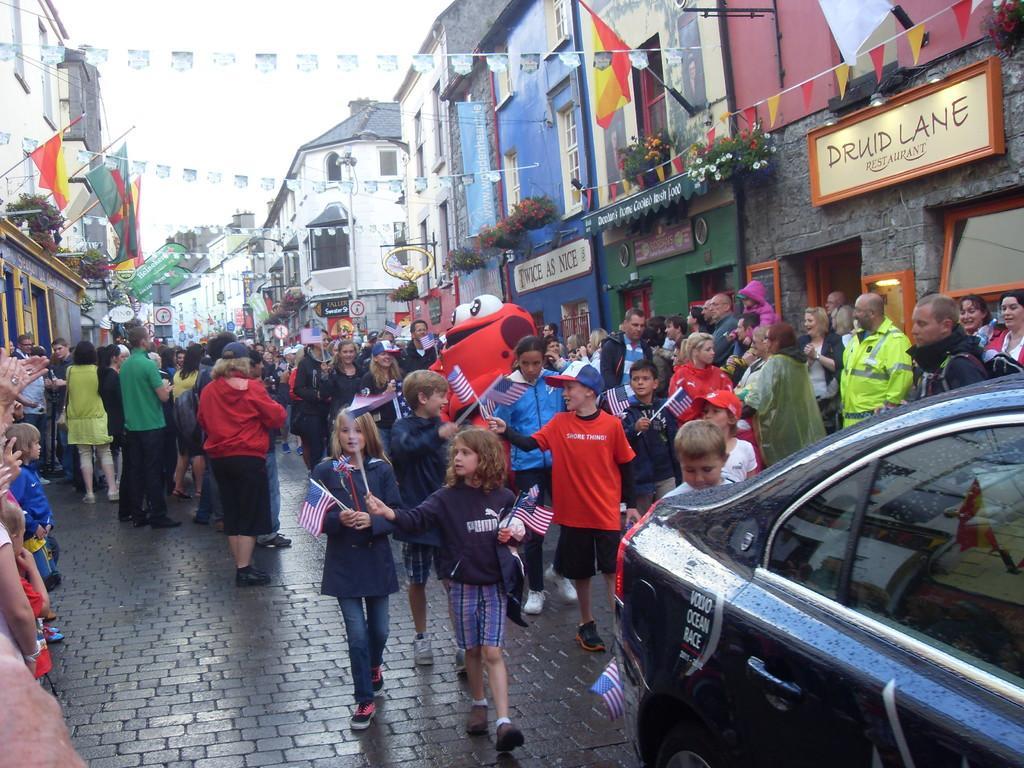Can you describe this image briefly? There is a crowd. Some are holding flags. Also there is a car. On the sides of the road there are buildings. On the buildings there are flags, pots with plants and name boards.. 